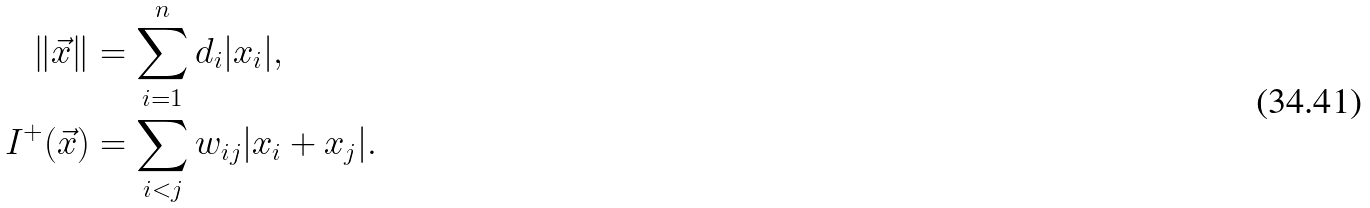<formula> <loc_0><loc_0><loc_500><loc_500>\| \vec { x } \| & = \sum _ { i = 1 } ^ { n } d _ { i } | x _ { i } | , \\ I ^ { + } ( \vec { x } ) & = \sum _ { i < j } w _ { i j } | x _ { i } + x _ { j } | .</formula> 